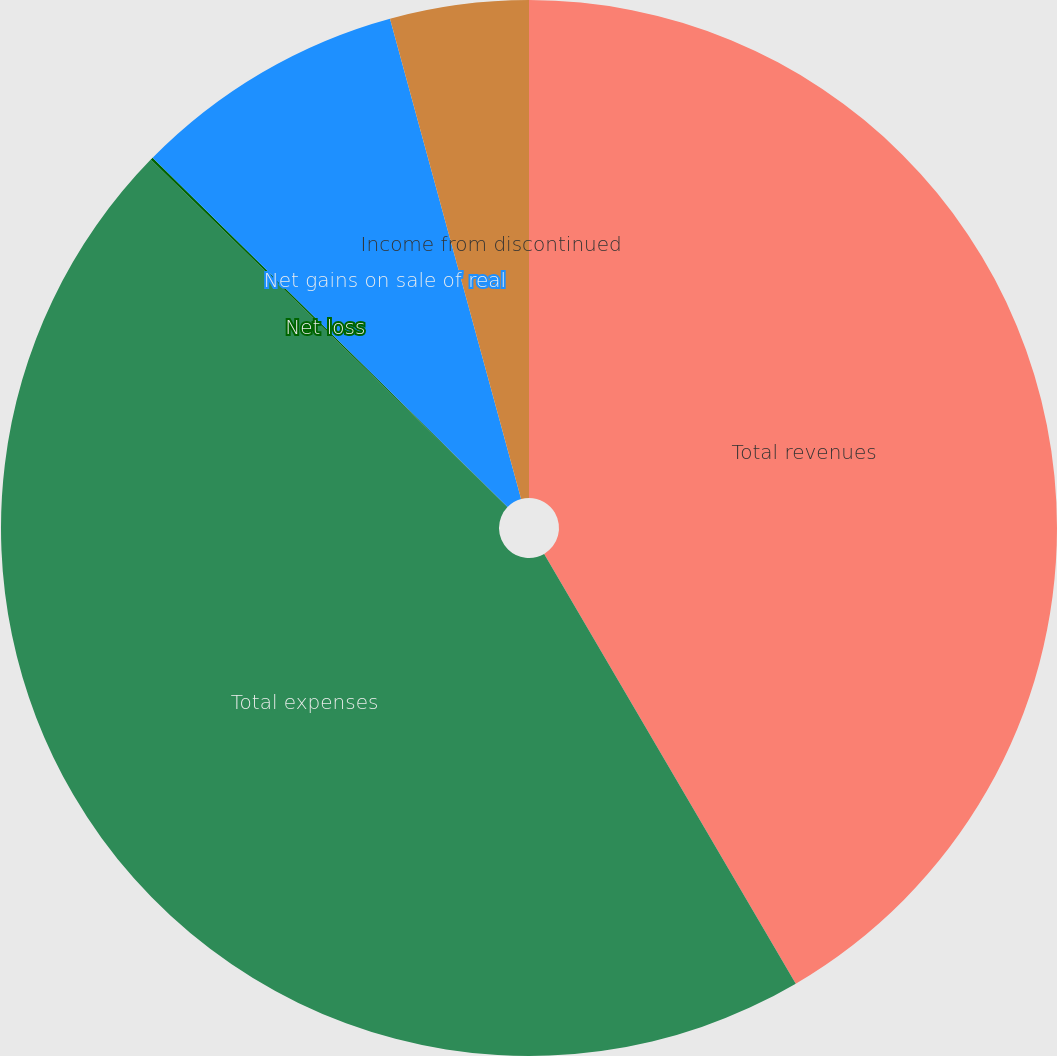Convert chart. <chart><loc_0><loc_0><loc_500><loc_500><pie_chart><fcel>Total revenues<fcel>Total expenses<fcel>Net loss<fcel>Net gains on sale of real<fcel>Income from discontinued<nl><fcel>41.57%<fcel>45.72%<fcel>0.08%<fcel>8.39%<fcel>4.24%<nl></chart> 